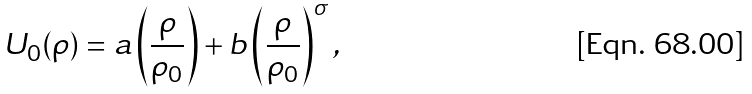<formula> <loc_0><loc_0><loc_500><loc_500>U _ { 0 } ( \rho ) = a \left ( \frac { \rho } { \rho _ { 0 } } \right ) + b \left ( \frac { \rho } { \rho _ { 0 } } \right ) ^ { \sigma } ,</formula> 